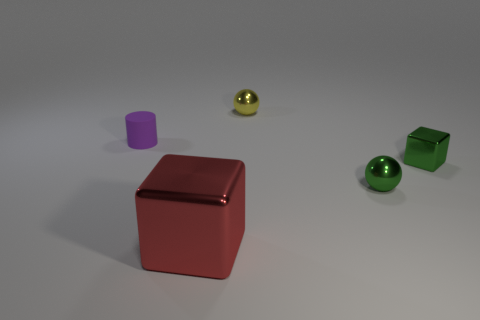Add 3 small green metal things. How many objects exist? 8 Add 1 large blue spheres. How many large blue spheres exist? 1 Subtract 0 gray cubes. How many objects are left? 5 Subtract all cylinders. How many objects are left? 4 Subtract all green blocks. Subtract all red cylinders. How many blocks are left? 1 Subtract all large purple matte spheres. Subtract all large red metal objects. How many objects are left? 4 Add 2 yellow metallic things. How many yellow metallic things are left? 3 